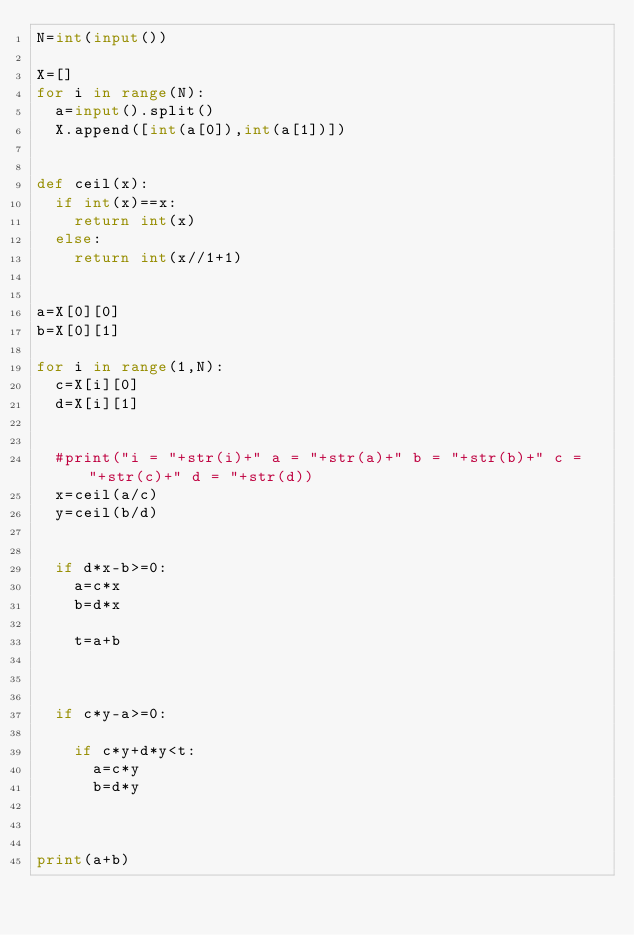<code> <loc_0><loc_0><loc_500><loc_500><_Python_>N=int(input())
 
X=[]
for i in range(N):
  a=input().split()
  X.append([int(a[0]),int(a[1])])
 
 
def ceil(x):
  if int(x)==x:
    return int(x)
  else:
    return int(x//1+1)
 
 
a=X[0][0]
b=X[0][1]
 
for i in range(1,N):
  c=X[i][0]
  d=X[i][1]
 
 
  #print("i = "+str(i)+" a = "+str(a)+" b = "+str(b)+" c = "+str(c)+" d = "+str(d))
  x=ceil(a/c)
  y=ceil(b/d)
  
 
  if d*x-b>=0:
    a=c*x
    b=d*x

    t=a+b

 
  
  if c*y-a>=0:

    if c*y+d*y<t:
      a=c*y
      b=d*y
 
 
  
print(a+b)</code> 